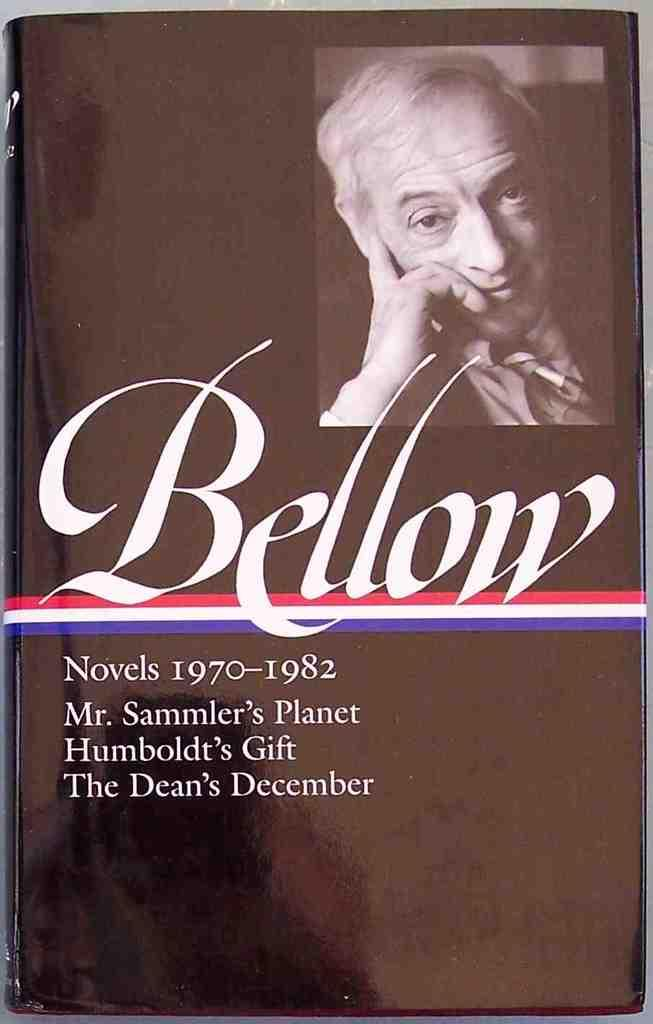What is the main object in the image? The image contains a book. What can be found inside the book? There is an image of a person in the book. Are there any words or text on the book? Yes, there is writing is present on the book. What type of snails can be seen crawling on the iron battlefield in the image? There is no mention of snails, iron, or a battlefield in the image; it only contains a book with an image of a person and writing. 